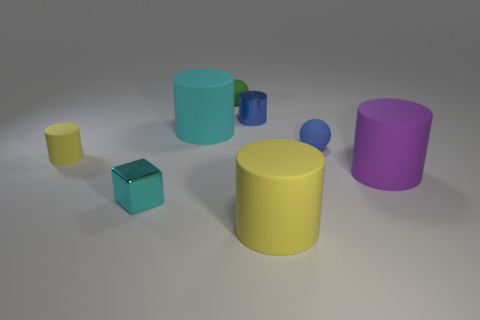Subtract all cyan cylinders. How many cylinders are left? 4 Subtract all blue metal cylinders. How many cylinders are left? 4 Subtract all gray cylinders. Subtract all cyan balls. How many cylinders are left? 5 Add 2 cyan metal objects. How many objects exist? 10 Subtract all cylinders. How many objects are left? 3 Add 1 big rubber cylinders. How many big rubber cylinders are left? 4 Add 5 big yellow rubber cubes. How many big yellow rubber cubes exist? 5 Subtract 0 yellow spheres. How many objects are left? 8 Subtract all tiny matte spheres. Subtract all green matte spheres. How many objects are left? 5 